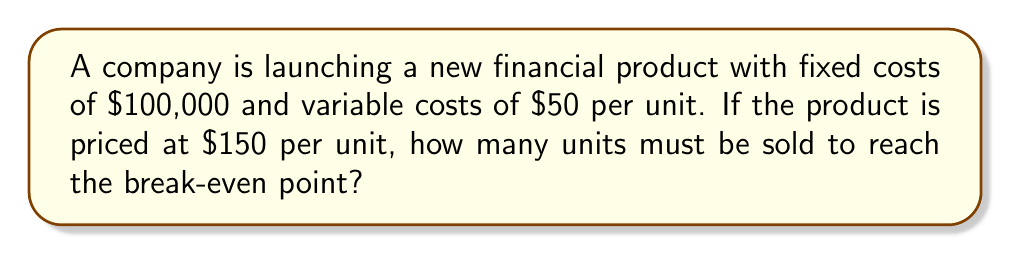Provide a solution to this math problem. To determine the break-even point, we need to find the number of units where total revenue equals total costs.

Let $x$ be the number of units sold.

1. Total Revenue: $TR = 150x$
2. Total Costs: $TC = 100,000 + 50x$

At the break-even point:
$TR = TC$

$$150x = 100,000 + 50x$$

Solving for $x$:
$$150x - 50x = 100,000$$
$$100x = 100,000$$
$$x = 1,000$$

To verify:
- Revenue: $150 \times 1,000 = 150,000$
- Costs: $100,000 + (50 \times 1,000) = 150,000$

Thus, at 1,000 units, revenue equals costs, confirming the break-even point.
Answer: 1,000 units 